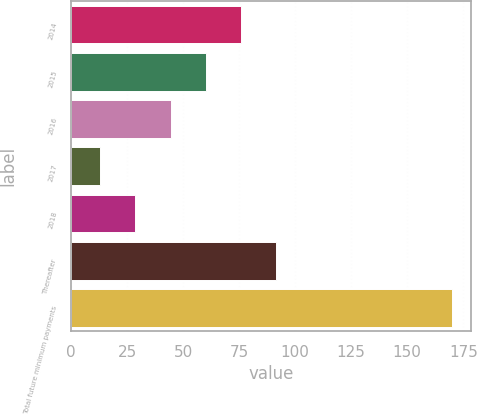Convert chart to OTSL. <chart><loc_0><loc_0><loc_500><loc_500><bar_chart><fcel>2014<fcel>2015<fcel>2016<fcel>2017<fcel>2018<fcel>Thereafter<fcel>Total future minimum payments<nl><fcel>75.8<fcel>60.1<fcel>44.4<fcel>13<fcel>28.7<fcel>91.5<fcel>170<nl></chart> 